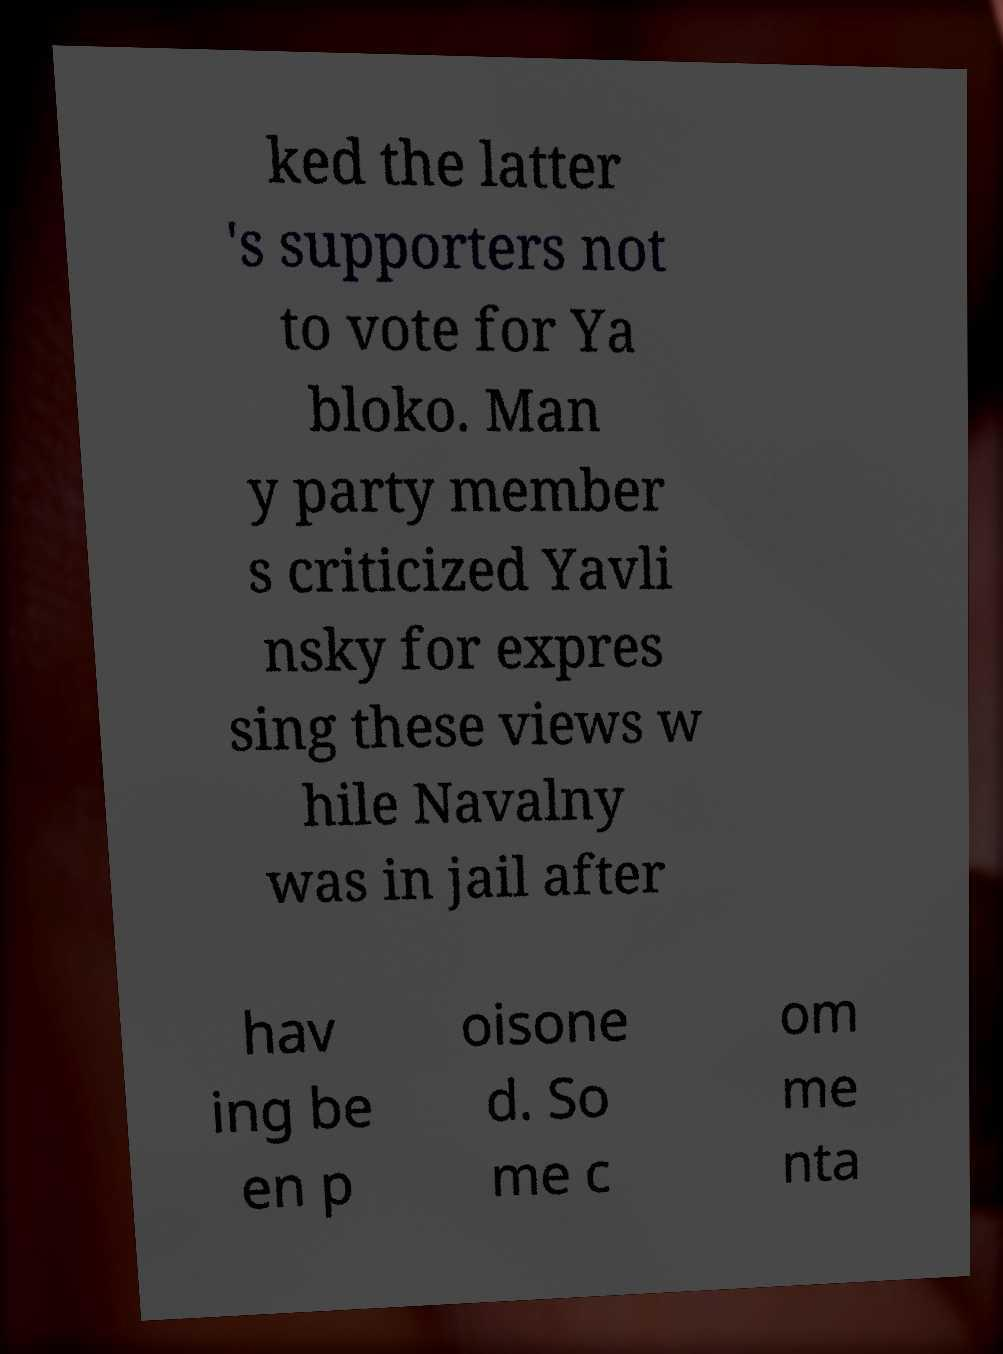Could you extract and type out the text from this image? ked the latter 's supporters not to vote for Ya bloko. Man y party member s criticized Yavli nsky for expres sing these views w hile Navalny was in jail after hav ing be en p oisone d. So me c om me nta 